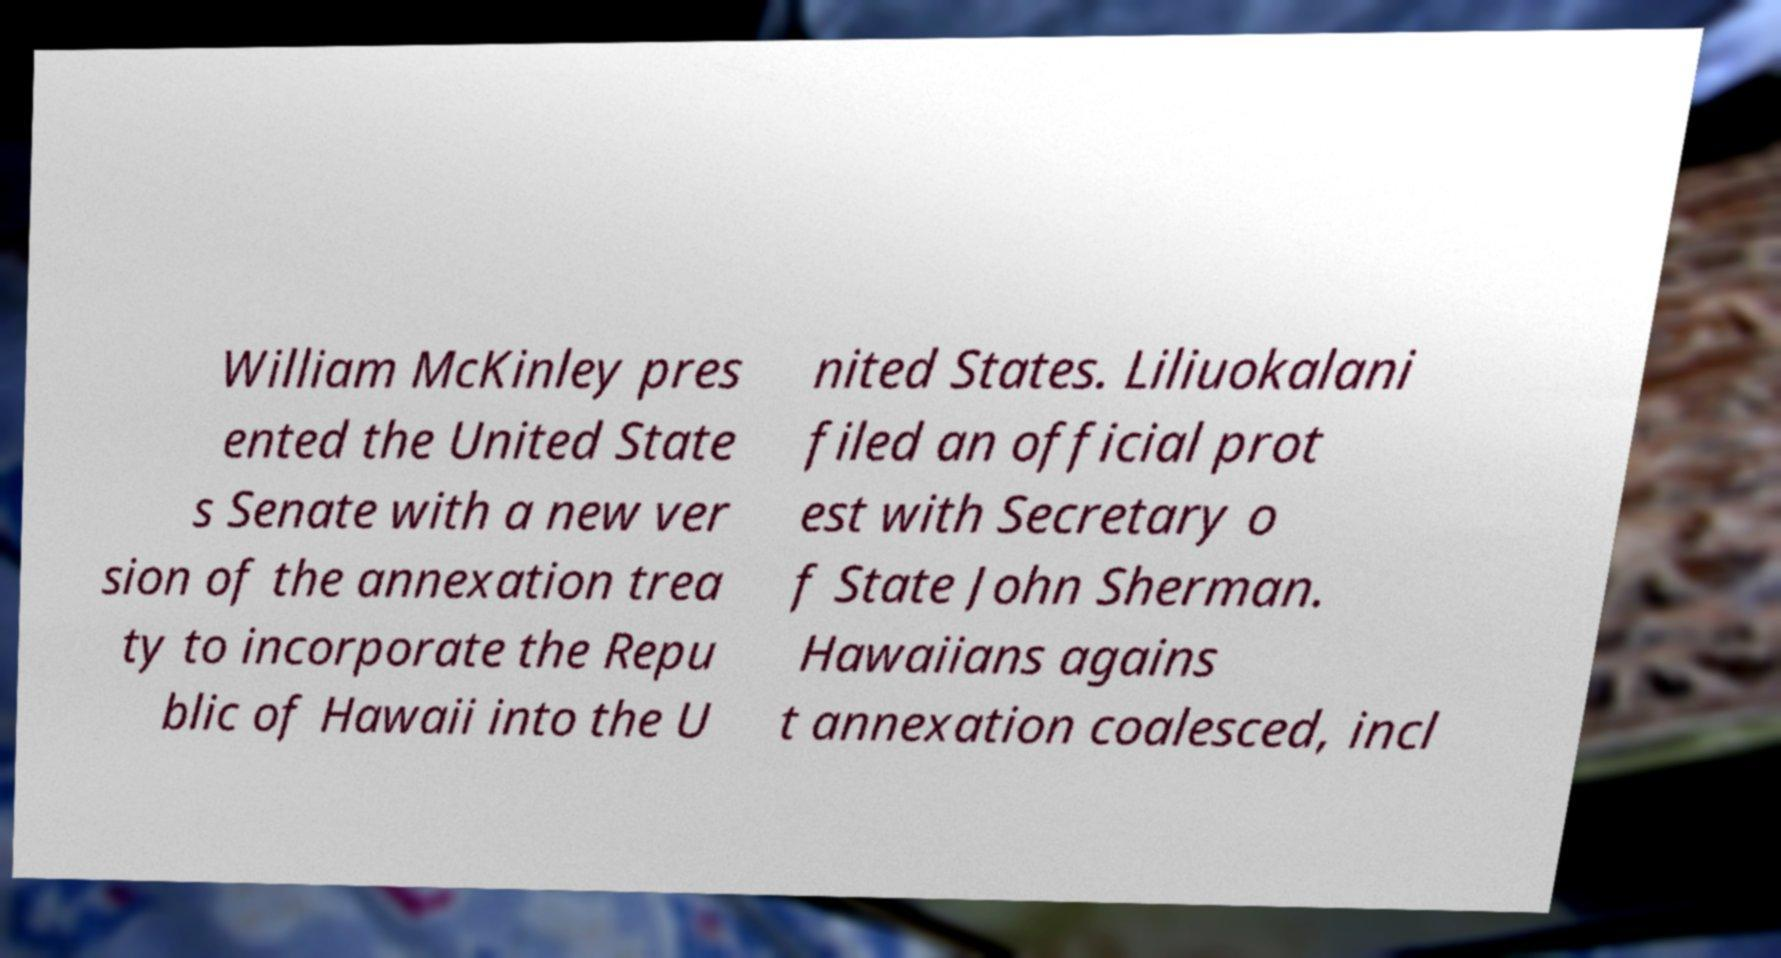What messages or text are displayed in this image? I need them in a readable, typed format. William McKinley pres ented the United State s Senate with a new ver sion of the annexation trea ty to incorporate the Repu blic of Hawaii into the U nited States. Liliuokalani filed an official prot est with Secretary o f State John Sherman. Hawaiians agains t annexation coalesced, incl 